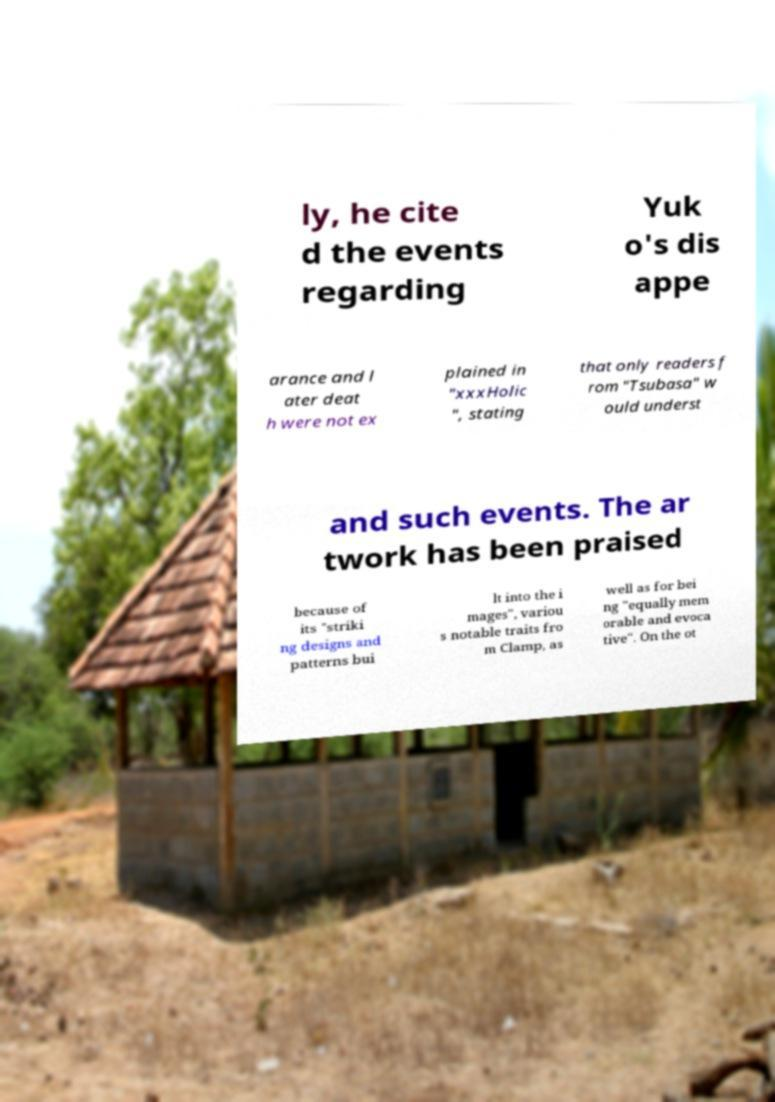Could you assist in decoding the text presented in this image and type it out clearly? ly, he cite d the events regarding Yuk o's dis appe arance and l ater deat h were not ex plained in "xxxHolic ", stating that only readers f rom "Tsubasa" w ould underst and such events. The ar twork has been praised because of its "striki ng designs and patterns bui lt into the i mages", variou s notable traits fro m Clamp, as well as for bei ng "equally mem orable and evoca tive". On the ot 